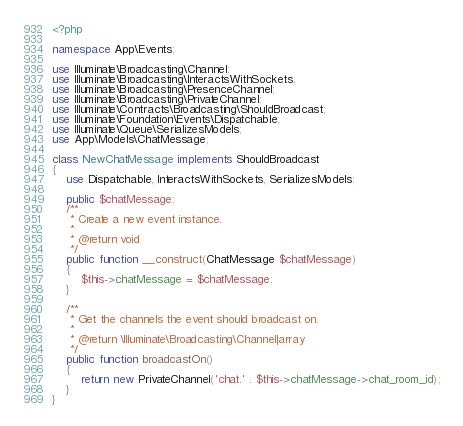Convert code to text. <code><loc_0><loc_0><loc_500><loc_500><_PHP_><?php

namespace App\Events;

use Illuminate\Broadcasting\Channel;
use Illuminate\Broadcasting\InteractsWithSockets;
use Illuminate\Broadcasting\PresenceChannel;
use Illuminate\Broadcasting\PrivateChannel;
use Illuminate\Contracts\Broadcasting\ShouldBroadcast;
use Illuminate\Foundation\Events\Dispatchable;
use Illuminate\Queue\SerializesModels;
use App\Models\ChatMessage;

class NewChatMessage implements ShouldBroadcast
{
    use Dispatchable, InteractsWithSockets, SerializesModels;

    public $chatMessage;
    /**
     * Create a new event instance.
     *
     * @return void
     */
    public function __construct(ChatMessage $chatMessage)
    {
        $this->chatMessage = $chatMessage;
    }

    /**
     * Get the channels the event should broadcast on.
     *
     * @return \Illuminate\Broadcasting\Channel|array
     */
    public function broadcastOn()
    {
        return new PrivateChannel('chat.' . $this->chatMessage->chat_room_id);
    }
}
</code> 